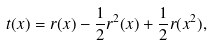Convert formula to latex. <formula><loc_0><loc_0><loc_500><loc_500>t ( x ) = r ( x ) - \frac { 1 } { 2 } r ^ { 2 } ( x ) + \frac { 1 } { 2 } r ( x ^ { 2 } ) ,</formula> 